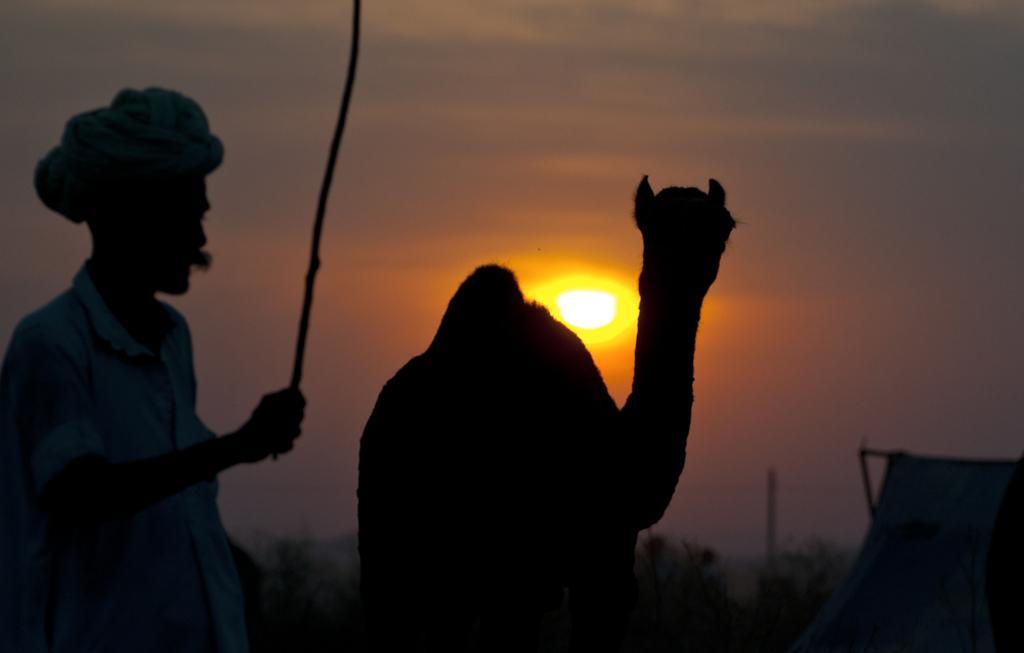Can you describe this image briefly? In this image I can see the person with the dress and holding the stick. To the side I can see an animal. In the background I can see the tent, trees, sun and the sky. 